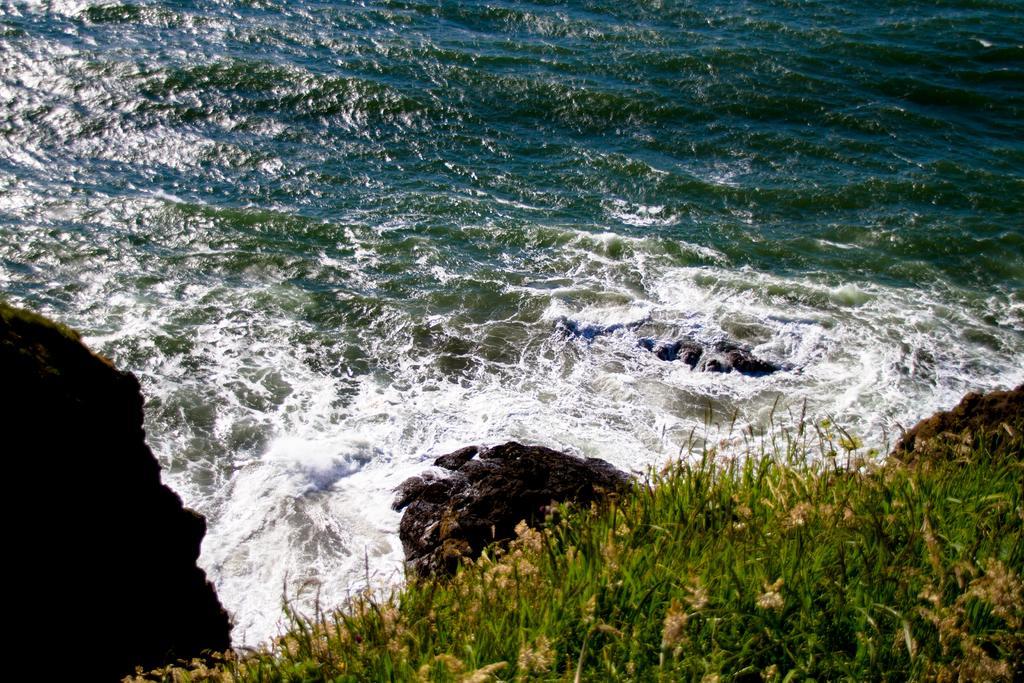Could you give a brief overview of what you see in this image? In this picture we can see planets at the bottom, in the background we can see water. 